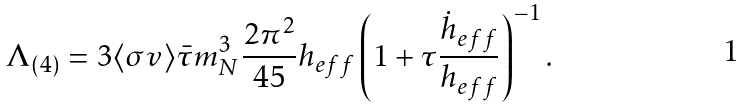<formula> <loc_0><loc_0><loc_500><loc_500>\Lambda _ { ( 4 ) } = 3 \langle \sigma v \rangle \bar { \tau } m _ { N } ^ { 3 } \frac { 2 \pi ^ { 2 } } { 4 5 } h _ { e f f } \left ( 1 + \tau \frac { \dot { h } _ { e f f } } { h _ { e f f } } \right ) ^ { - 1 } .</formula> 